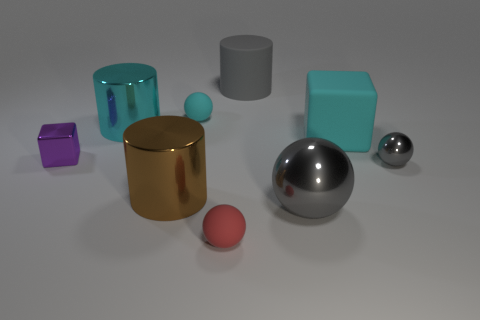The tiny shiny ball is what color?
Make the answer very short. Gray. Do the large metal ball and the cylinder to the right of the cyan rubber ball have the same color?
Make the answer very short. Yes. Are there any objects that have the same size as the cyan metallic cylinder?
Ensure brevity in your answer.  Yes. What size is the shiny thing that is the same color as the big ball?
Make the answer very short. Small. There is a ball that is right of the large block; what is it made of?
Offer a terse response. Metal. Are there the same number of gray matte cylinders in front of the big brown metal object and gray matte cylinders that are left of the small cyan ball?
Your response must be concise. Yes. There is a rubber object in front of the tiny metal ball; does it have the same size as the cylinder in front of the cyan cylinder?
Your answer should be very brief. No. What number of large shiny balls are the same color as the big rubber cube?
Keep it short and to the point. 0. There is another ball that is the same color as the small shiny ball; what is it made of?
Your answer should be compact. Metal. Are there more tiny metal cubes that are in front of the tiny red sphere than large metallic things?
Provide a succinct answer. No. 